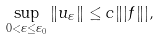Convert formula to latex. <formula><loc_0><loc_0><loc_500><loc_500>\sup _ { 0 < \varepsilon \leq \varepsilon _ { 0 } } \| u _ { \varepsilon } \| \leq c \| | f \| | ,</formula> 